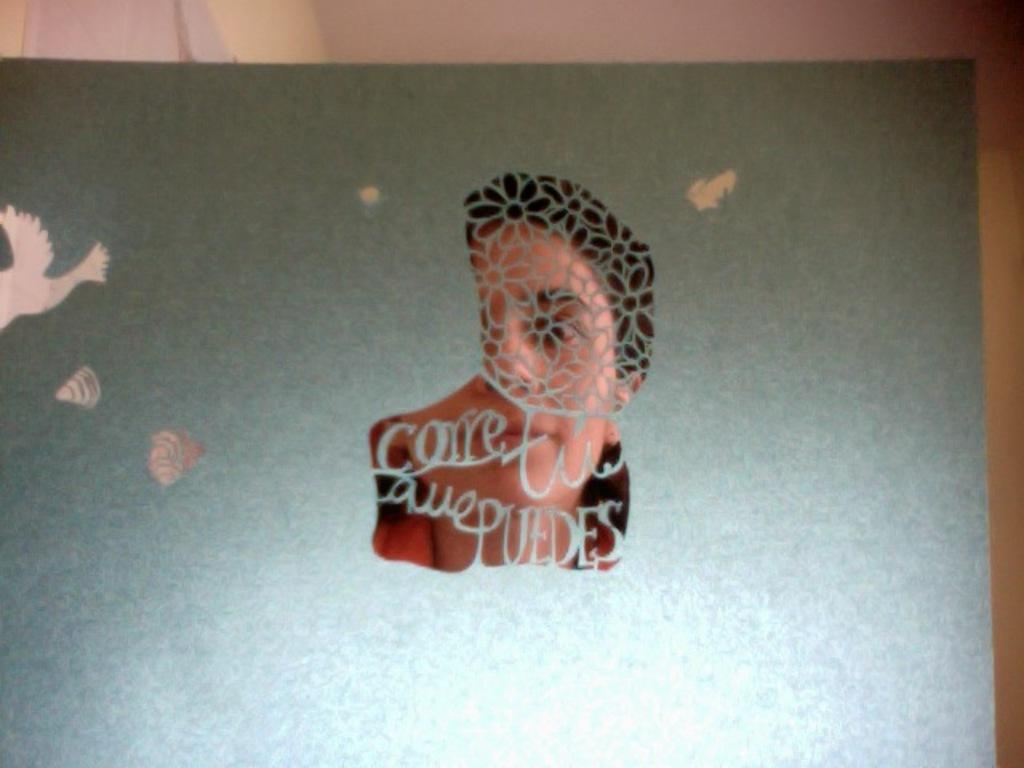What is present on the paper in the image? There is a photo of a girl on the paper in the image. What else can be seen on the paper besides the photo? There is text on the paper. What type of paste is being used to attach the paper to the wall in the image? There is no paste or wall attachment visible in the image; it only shows the paper with a photo and text. What emotions or feelings can be observed on the girl's face in the photo? The image does not provide enough detail to determine the girl's emotions or feelings in the photo. 